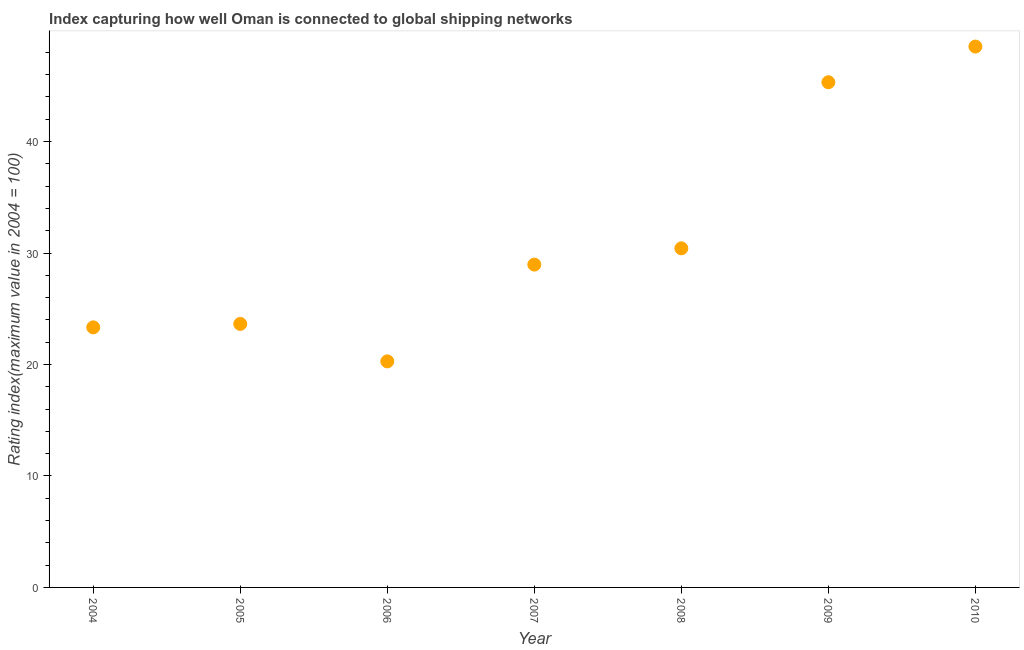What is the liner shipping connectivity index in 2007?
Your response must be concise. 28.96. Across all years, what is the maximum liner shipping connectivity index?
Give a very brief answer. 48.52. Across all years, what is the minimum liner shipping connectivity index?
Give a very brief answer. 20.28. In which year was the liner shipping connectivity index maximum?
Offer a very short reply. 2010. In which year was the liner shipping connectivity index minimum?
Your response must be concise. 2006. What is the sum of the liner shipping connectivity index?
Provide a short and direct response. 220.47. What is the difference between the liner shipping connectivity index in 2004 and 2006?
Keep it short and to the point. 3.05. What is the average liner shipping connectivity index per year?
Your response must be concise. 31.5. What is the median liner shipping connectivity index?
Provide a succinct answer. 28.96. In how many years, is the liner shipping connectivity index greater than 2 ?
Ensure brevity in your answer.  7. Do a majority of the years between 2010 and 2008 (inclusive) have liner shipping connectivity index greater than 46 ?
Your response must be concise. No. What is the ratio of the liner shipping connectivity index in 2009 to that in 2010?
Your answer should be compact. 0.93. Is the liner shipping connectivity index in 2006 less than that in 2008?
Make the answer very short. Yes. What is the difference between the highest and the second highest liner shipping connectivity index?
Give a very brief answer. 3.2. Is the sum of the liner shipping connectivity index in 2004 and 2006 greater than the maximum liner shipping connectivity index across all years?
Offer a terse response. No. What is the difference between the highest and the lowest liner shipping connectivity index?
Offer a very short reply. 28.24. In how many years, is the liner shipping connectivity index greater than the average liner shipping connectivity index taken over all years?
Ensure brevity in your answer.  2. Does the liner shipping connectivity index monotonically increase over the years?
Ensure brevity in your answer.  No. How many years are there in the graph?
Ensure brevity in your answer.  7. What is the difference between two consecutive major ticks on the Y-axis?
Keep it short and to the point. 10. Are the values on the major ticks of Y-axis written in scientific E-notation?
Keep it short and to the point. No. Does the graph contain grids?
Offer a very short reply. No. What is the title of the graph?
Offer a terse response. Index capturing how well Oman is connected to global shipping networks. What is the label or title of the X-axis?
Ensure brevity in your answer.  Year. What is the label or title of the Y-axis?
Make the answer very short. Rating index(maximum value in 2004 = 100). What is the Rating index(maximum value in 2004 = 100) in 2004?
Keep it short and to the point. 23.33. What is the Rating index(maximum value in 2004 = 100) in 2005?
Your answer should be compact. 23.64. What is the Rating index(maximum value in 2004 = 100) in 2006?
Give a very brief answer. 20.28. What is the Rating index(maximum value in 2004 = 100) in 2007?
Provide a succinct answer. 28.96. What is the Rating index(maximum value in 2004 = 100) in 2008?
Your response must be concise. 30.42. What is the Rating index(maximum value in 2004 = 100) in 2009?
Your answer should be very brief. 45.32. What is the Rating index(maximum value in 2004 = 100) in 2010?
Ensure brevity in your answer.  48.52. What is the difference between the Rating index(maximum value in 2004 = 100) in 2004 and 2005?
Your answer should be very brief. -0.31. What is the difference between the Rating index(maximum value in 2004 = 100) in 2004 and 2006?
Give a very brief answer. 3.05. What is the difference between the Rating index(maximum value in 2004 = 100) in 2004 and 2007?
Offer a very short reply. -5.63. What is the difference between the Rating index(maximum value in 2004 = 100) in 2004 and 2008?
Your response must be concise. -7.09. What is the difference between the Rating index(maximum value in 2004 = 100) in 2004 and 2009?
Provide a short and direct response. -21.99. What is the difference between the Rating index(maximum value in 2004 = 100) in 2004 and 2010?
Make the answer very short. -25.19. What is the difference between the Rating index(maximum value in 2004 = 100) in 2005 and 2006?
Provide a short and direct response. 3.36. What is the difference between the Rating index(maximum value in 2004 = 100) in 2005 and 2007?
Provide a short and direct response. -5.32. What is the difference between the Rating index(maximum value in 2004 = 100) in 2005 and 2008?
Your response must be concise. -6.78. What is the difference between the Rating index(maximum value in 2004 = 100) in 2005 and 2009?
Provide a succinct answer. -21.68. What is the difference between the Rating index(maximum value in 2004 = 100) in 2005 and 2010?
Give a very brief answer. -24.88. What is the difference between the Rating index(maximum value in 2004 = 100) in 2006 and 2007?
Provide a succinct answer. -8.68. What is the difference between the Rating index(maximum value in 2004 = 100) in 2006 and 2008?
Give a very brief answer. -10.14. What is the difference between the Rating index(maximum value in 2004 = 100) in 2006 and 2009?
Offer a very short reply. -25.04. What is the difference between the Rating index(maximum value in 2004 = 100) in 2006 and 2010?
Provide a succinct answer. -28.24. What is the difference between the Rating index(maximum value in 2004 = 100) in 2007 and 2008?
Make the answer very short. -1.46. What is the difference between the Rating index(maximum value in 2004 = 100) in 2007 and 2009?
Provide a short and direct response. -16.36. What is the difference between the Rating index(maximum value in 2004 = 100) in 2007 and 2010?
Provide a short and direct response. -19.56. What is the difference between the Rating index(maximum value in 2004 = 100) in 2008 and 2009?
Your response must be concise. -14.9. What is the difference between the Rating index(maximum value in 2004 = 100) in 2008 and 2010?
Provide a short and direct response. -18.1. What is the ratio of the Rating index(maximum value in 2004 = 100) in 2004 to that in 2006?
Make the answer very short. 1.15. What is the ratio of the Rating index(maximum value in 2004 = 100) in 2004 to that in 2007?
Ensure brevity in your answer.  0.81. What is the ratio of the Rating index(maximum value in 2004 = 100) in 2004 to that in 2008?
Your answer should be compact. 0.77. What is the ratio of the Rating index(maximum value in 2004 = 100) in 2004 to that in 2009?
Keep it short and to the point. 0.52. What is the ratio of the Rating index(maximum value in 2004 = 100) in 2004 to that in 2010?
Offer a very short reply. 0.48. What is the ratio of the Rating index(maximum value in 2004 = 100) in 2005 to that in 2006?
Your response must be concise. 1.17. What is the ratio of the Rating index(maximum value in 2004 = 100) in 2005 to that in 2007?
Provide a short and direct response. 0.82. What is the ratio of the Rating index(maximum value in 2004 = 100) in 2005 to that in 2008?
Make the answer very short. 0.78. What is the ratio of the Rating index(maximum value in 2004 = 100) in 2005 to that in 2009?
Your response must be concise. 0.52. What is the ratio of the Rating index(maximum value in 2004 = 100) in 2005 to that in 2010?
Your response must be concise. 0.49. What is the ratio of the Rating index(maximum value in 2004 = 100) in 2006 to that in 2007?
Your answer should be very brief. 0.7. What is the ratio of the Rating index(maximum value in 2004 = 100) in 2006 to that in 2008?
Give a very brief answer. 0.67. What is the ratio of the Rating index(maximum value in 2004 = 100) in 2006 to that in 2009?
Provide a short and direct response. 0.45. What is the ratio of the Rating index(maximum value in 2004 = 100) in 2006 to that in 2010?
Offer a terse response. 0.42. What is the ratio of the Rating index(maximum value in 2004 = 100) in 2007 to that in 2008?
Your answer should be very brief. 0.95. What is the ratio of the Rating index(maximum value in 2004 = 100) in 2007 to that in 2009?
Ensure brevity in your answer.  0.64. What is the ratio of the Rating index(maximum value in 2004 = 100) in 2007 to that in 2010?
Your response must be concise. 0.6. What is the ratio of the Rating index(maximum value in 2004 = 100) in 2008 to that in 2009?
Your response must be concise. 0.67. What is the ratio of the Rating index(maximum value in 2004 = 100) in 2008 to that in 2010?
Give a very brief answer. 0.63. What is the ratio of the Rating index(maximum value in 2004 = 100) in 2009 to that in 2010?
Your answer should be compact. 0.93. 